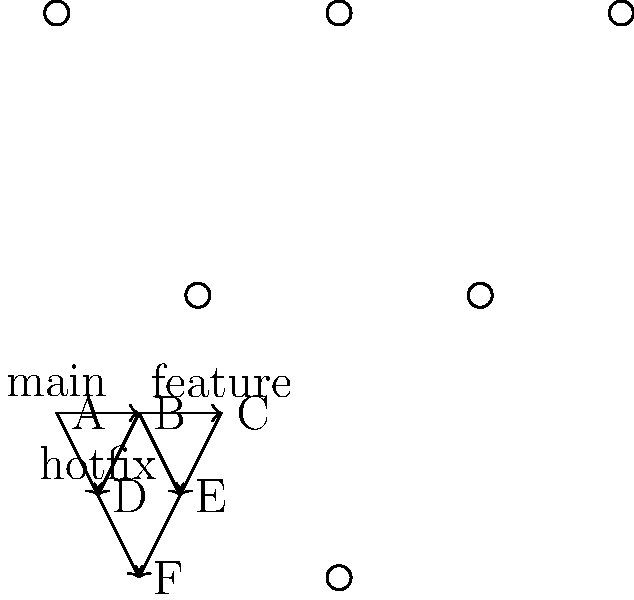Given the Git branch structure shown in the diagram, which merge strategy would be most appropriate to integrate the 'hotfix' branch (D-F) into both 'main' and 'feature' branches while preserving the commit history and maintaining a clean Git log? To determine the most appropriate merge strategy, let's analyze the branch structure and consider the requirements:

1. The 'hotfix' branch (D-F) needs to be integrated into both 'main' and 'feature' branches.
2. We want to preserve the commit history.
3. We need to maintain a clean Git log.

Given these requirements, the most suitable strategy would be to use a combination of cherry-pick and merge:

Step 1: Cherry-pick the hotfix commits to the 'main' branch.
```
git checkout main
git cherry-pick D F
```
This will apply the changes from commits D and F to the 'main' branch.

Step 2: Merge the updated 'main' branch into the 'feature' branch.
```
git checkout feature
git merge main
```

This approach has several advantages:
1. It preserves the commit history of the hotfix.
2. It maintains a clean and linear history on the 'main' branch.
3. It ensures that both 'main' and 'feature' branches receive the hotfix.
4. It avoids creating unnecessary merge commits.

An alternative approach could be to use rebase, but this might cause issues if the 'hotfix' branch has already been pushed to a shared repository, as it rewrites history.

The cherry-pick and merge strategy is particularly suitable for experienced developers who are comfortable with more advanced Git operations and understand the importance of maintaining a clean, meaningful commit history.
Answer: Cherry-pick to main, then merge main to feature 